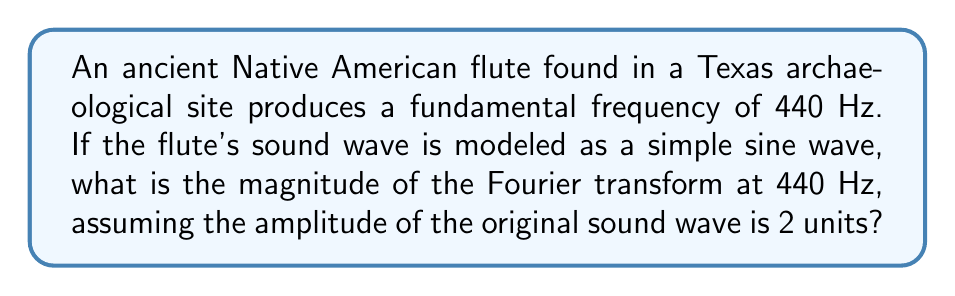What is the answer to this math problem? Let's approach this step-by-step:

1) The sound wave can be modeled as:
   $$f(t) = 2 \sin(2\pi \cdot 440t)$$

2) The Fourier transform of a sine wave is given by:
   $$F(\omega) = i\pi[δ(\omega + \omega_0) - δ(\omega - \omega_0)]$$
   where $\omega_0 = 2\pi f_0$, and $f_0$ is the frequency of the sine wave.

3) In this case, $f_0 = 440$ Hz, so $\omega_0 = 2\pi \cdot 440$.

4) The amplitude of the original wave is 2, so we need to multiply our Fourier transform by 2:
   $$F(\omega) = 2i\pi[δ(\omega + 2\pi \cdot 440) - δ(\omega - 2\pi \cdot 440)]$$

5) The magnitude of the Fourier transform at $\omega = 2\pi \cdot 440$ is:
   $$|F(2\pi \cdot 440)| = |2i\pi \cdot (-1)| = 2\pi$$

6) Therefore, the magnitude of the Fourier transform at 440 Hz is $2\pi$.
Answer: $2\pi$ 